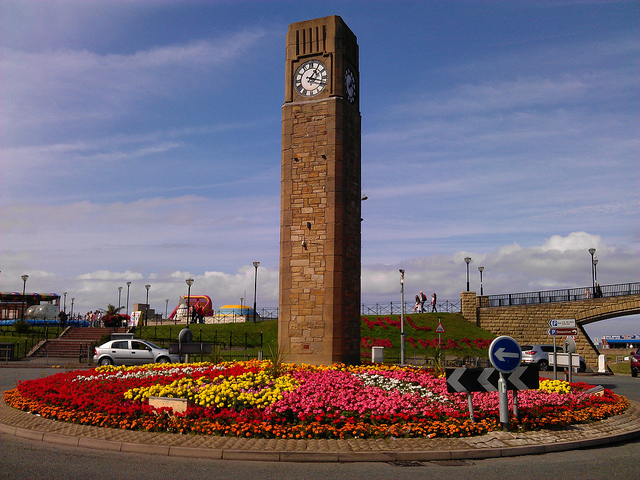<image>What tower is this? I don't know what tower this is. It could be 'Big Ben' or a 'clock tower'. What is the brick structure to the far right of the photo? I am not sure about the brick structure to the far right of the photo. It could be a bridge or steps. What is the name of the tower? It's ambiguous what the name of the tower is. It could potentially be the "clock tower" or "big ben". How tall is the monument? I am not sure how tall the monument is. The height can be any of the given options - 20 feet, 50 feet, 5 ft or 15 ft. What monument is in the background? I'm not sure what the monument in the background is. It might be a clock tower or a clock. What tower is this? I don't know what tower this is. It can be Big Ben, Clock Tower or just a clock. What is the brick structure to the far right of the photo? I don't know what the brick structure to the far right of the photo is. It can be a clock, bridge or steps. What is the name of the tower? It is ambiguous what the name of the tower is. It can be called 'clock', 'clock tower', 'brick', 'big ben', or 'central clock tower'. How tall is the monument? I am not sure how tall the monument is. It could be around 20 feet to 100 feet. What monument is in the background? I am not sure which monument is in the background. It can be seen as a clock tower or just a tower. 